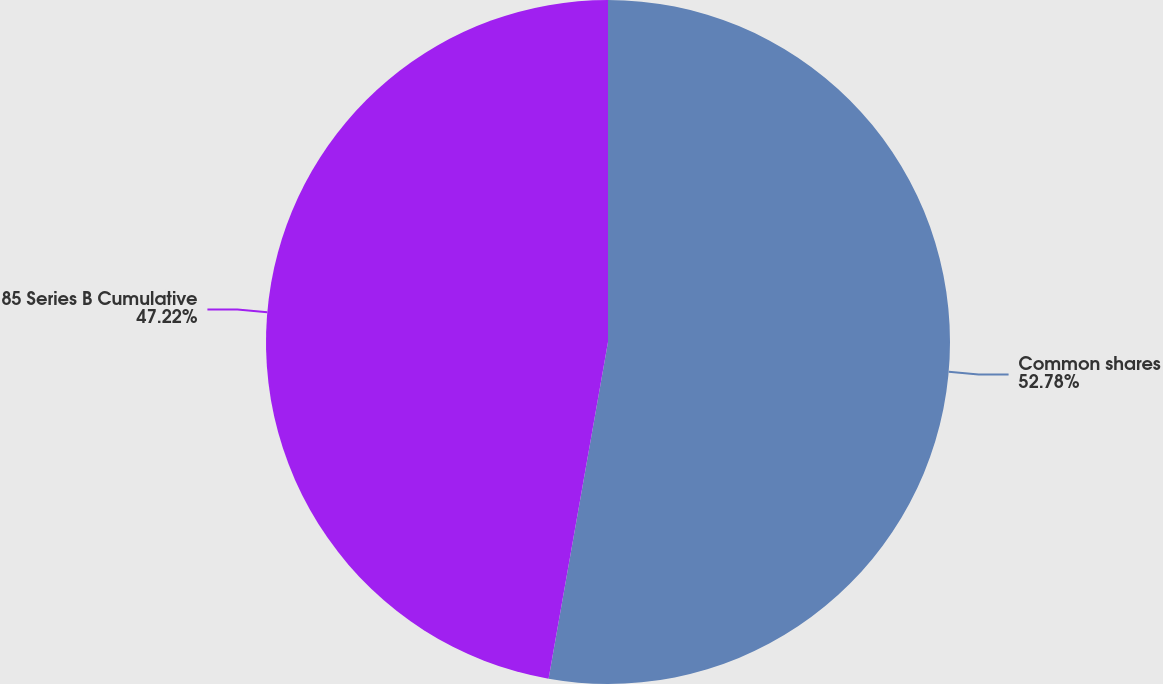Convert chart to OTSL. <chart><loc_0><loc_0><loc_500><loc_500><pie_chart><fcel>Common shares<fcel>85 Series B Cumulative<nl><fcel>52.78%<fcel>47.22%<nl></chart> 